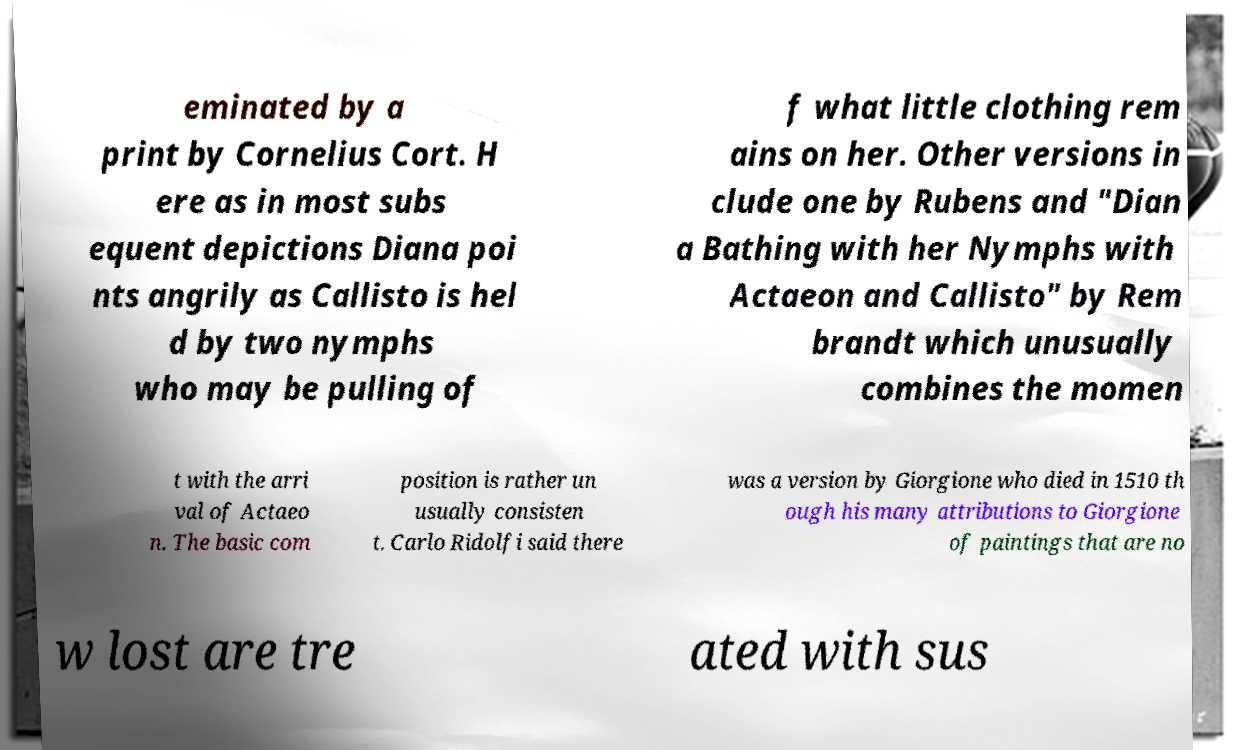What messages or text are displayed in this image? I need them in a readable, typed format. eminated by a print by Cornelius Cort. H ere as in most subs equent depictions Diana poi nts angrily as Callisto is hel d by two nymphs who may be pulling of f what little clothing rem ains on her. Other versions in clude one by Rubens and "Dian a Bathing with her Nymphs with Actaeon and Callisto" by Rem brandt which unusually combines the momen t with the arri val of Actaeo n. The basic com position is rather un usually consisten t. Carlo Ridolfi said there was a version by Giorgione who died in 1510 th ough his many attributions to Giorgione of paintings that are no w lost are tre ated with sus 